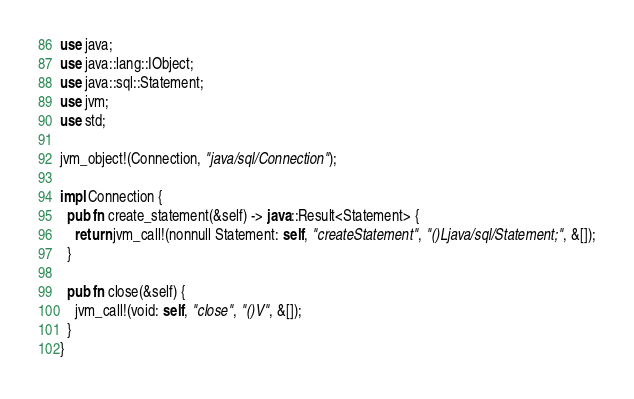<code> <loc_0><loc_0><loc_500><loc_500><_Rust_>use java;
use java::lang::IObject;
use java::sql::Statement;
use jvm;
use std;

jvm_object!(Connection, "java/sql/Connection");

impl Connection {
  pub fn create_statement(&self) -> java::Result<Statement> {
    return jvm_call!(nonnull Statement: self, "createStatement", "()Ljava/sql/Statement;", &[]);
  }

  pub fn close(&self) {
    jvm_call!(void: self, "close", "()V", &[]);
  }
}
</code> 